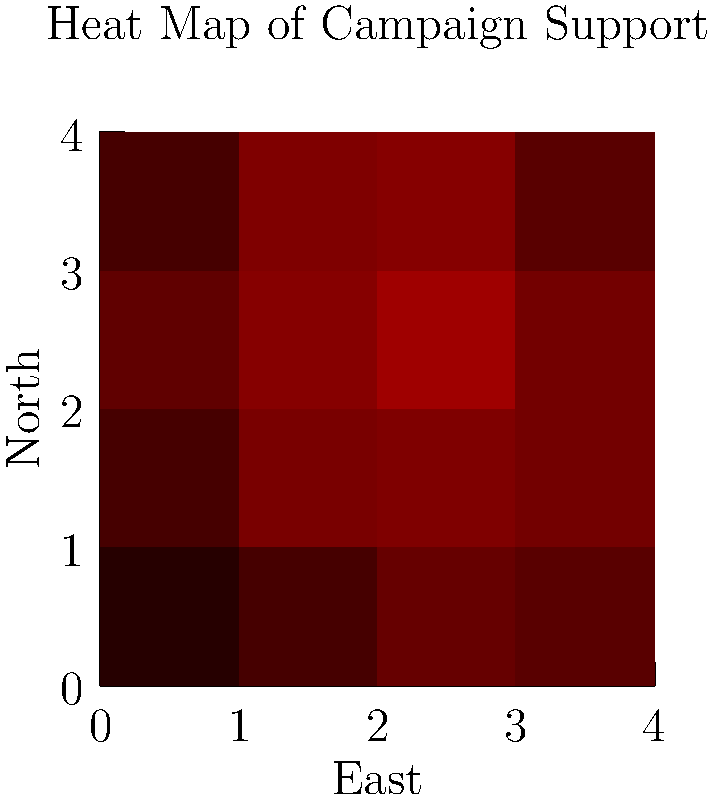As the communications director, you're analyzing a heat map of campaign supporter distribution. The map shows a 4x4 grid representing different regions, with darker red indicating higher support. Which quadrant of the map shows the highest concentration of support, and how might this information influence your messaging strategy? To answer this question, let's analyze the heat map step-by-step:

1. The heat map is divided into a 4x4 grid, effectively creating four quadrants:
   - Northwest (top-left)
   - Northeast (top-right)
   - Southwest (bottom-left)
   - Southeast (bottom-right)

2. The intensity of red color indicates the level of support, with darker red showing higher concentration.

3. Examining each quadrant:
   - Northwest: Moderate support, with one dark cell
   - Northeast: Highest overall intensity, with two very dark cells
   - Southwest: Generally light, indicating lower support
   - Southeast: Moderate support, similar to Northwest

4. The Northeast quadrant clearly shows the highest concentration of support.

5. This information can influence messaging strategy in several ways:
   a. Focus resources on maintaining strong support in the Northeast
   b. Tailor messages to address issues important to Northeast constituents
   c. Use success in Northeast as a model for other regions
   d. Develop strategies to increase support in less supportive areas, especially Southwest

6. As a communications director, you might:
   - Highlight the congressman's achievements that benefited the Northeast
   - Organize more events in the Northeast to capitalize on existing support
   - Create targeted campaigns for other regions based on Northeast success stories
   - Analyze what factors contribute to strong Northeast support and apply insights elsewhere
Answer: Northeast quadrant; focus on maintaining strength there while using its success as a model for other regions. 